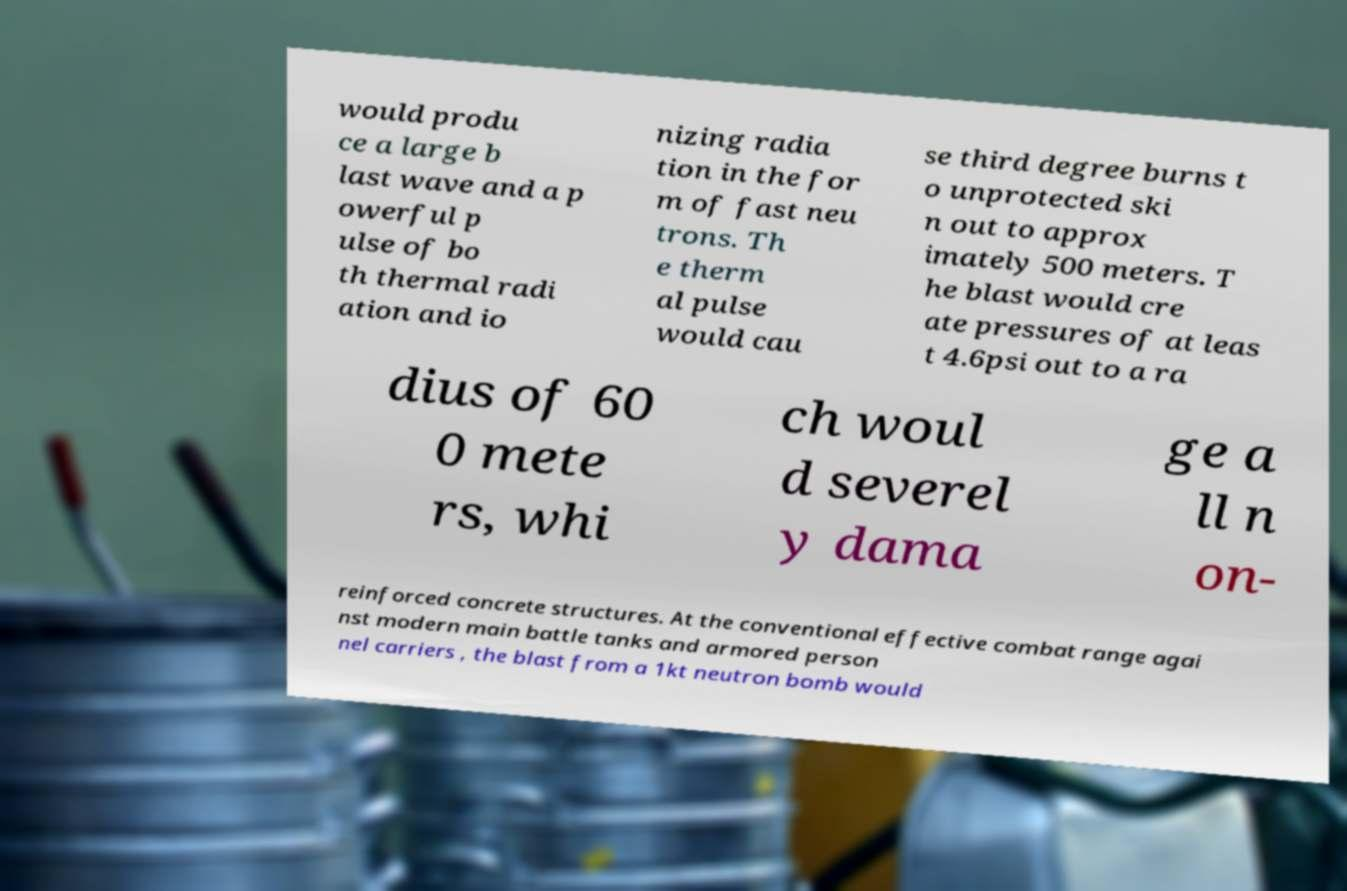Please identify and transcribe the text found in this image. would produ ce a large b last wave and a p owerful p ulse of bo th thermal radi ation and io nizing radia tion in the for m of fast neu trons. Th e therm al pulse would cau se third degree burns t o unprotected ski n out to approx imately 500 meters. T he blast would cre ate pressures of at leas t 4.6psi out to a ra dius of 60 0 mete rs, whi ch woul d severel y dama ge a ll n on- reinforced concrete structures. At the conventional effective combat range agai nst modern main battle tanks and armored person nel carriers , the blast from a 1kt neutron bomb would 